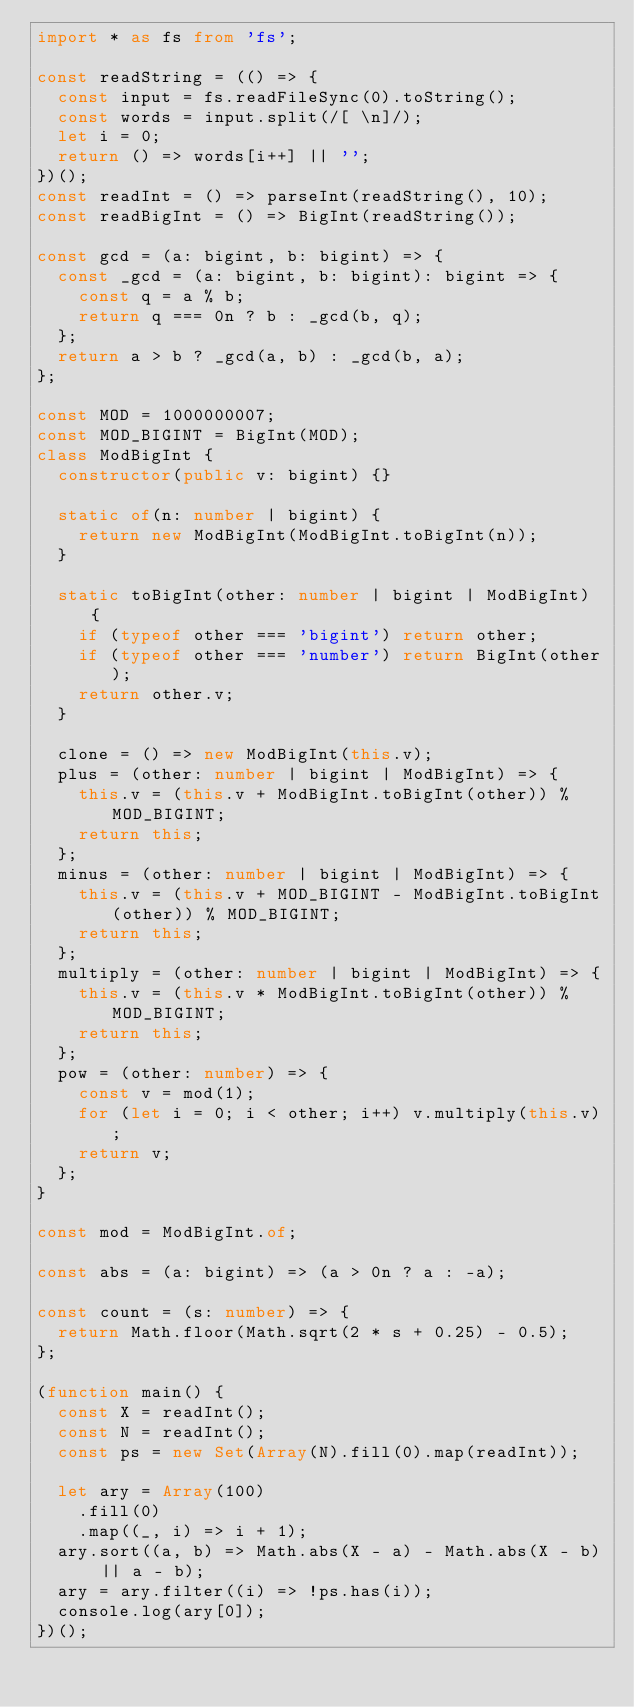<code> <loc_0><loc_0><loc_500><loc_500><_TypeScript_>import * as fs from 'fs';

const readString = (() => {
  const input = fs.readFileSync(0).toString();
  const words = input.split(/[ \n]/);
  let i = 0;
  return () => words[i++] || '';
})();
const readInt = () => parseInt(readString(), 10);
const readBigInt = () => BigInt(readString());

const gcd = (a: bigint, b: bigint) => {
  const _gcd = (a: bigint, b: bigint): bigint => {
    const q = a % b;
    return q === 0n ? b : _gcd(b, q);
  };
  return a > b ? _gcd(a, b) : _gcd(b, a);
};

const MOD = 1000000007;
const MOD_BIGINT = BigInt(MOD);
class ModBigInt {
  constructor(public v: bigint) {}

  static of(n: number | bigint) {
    return new ModBigInt(ModBigInt.toBigInt(n));
  }

  static toBigInt(other: number | bigint | ModBigInt) {
    if (typeof other === 'bigint') return other;
    if (typeof other === 'number') return BigInt(other);
    return other.v;
  }

  clone = () => new ModBigInt(this.v);
  plus = (other: number | bigint | ModBigInt) => {
    this.v = (this.v + ModBigInt.toBigInt(other)) % MOD_BIGINT;
    return this;
  };
  minus = (other: number | bigint | ModBigInt) => {
    this.v = (this.v + MOD_BIGINT - ModBigInt.toBigInt(other)) % MOD_BIGINT;
    return this;
  };
  multiply = (other: number | bigint | ModBigInt) => {
    this.v = (this.v * ModBigInt.toBigInt(other)) % MOD_BIGINT;
    return this;
  };
  pow = (other: number) => {
    const v = mod(1);
    for (let i = 0; i < other; i++) v.multiply(this.v);
    return v;
  };
}

const mod = ModBigInt.of;

const abs = (a: bigint) => (a > 0n ? a : -a);

const count = (s: number) => {
  return Math.floor(Math.sqrt(2 * s + 0.25) - 0.5);
};

(function main() {
  const X = readInt();
  const N = readInt();
  const ps = new Set(Array(N).fill(0).map(readInt));

  let ary = Array(100)
    .fill(0)
    .map((_, i) => i + 1);
  ary.sort((a, b) => Math.abs(X - a) - Math.abs(X - b) || a - b);
  ary = ary.filter((i) => !ps.has(i));
  console.log(ary[0]);
})();
</code> 